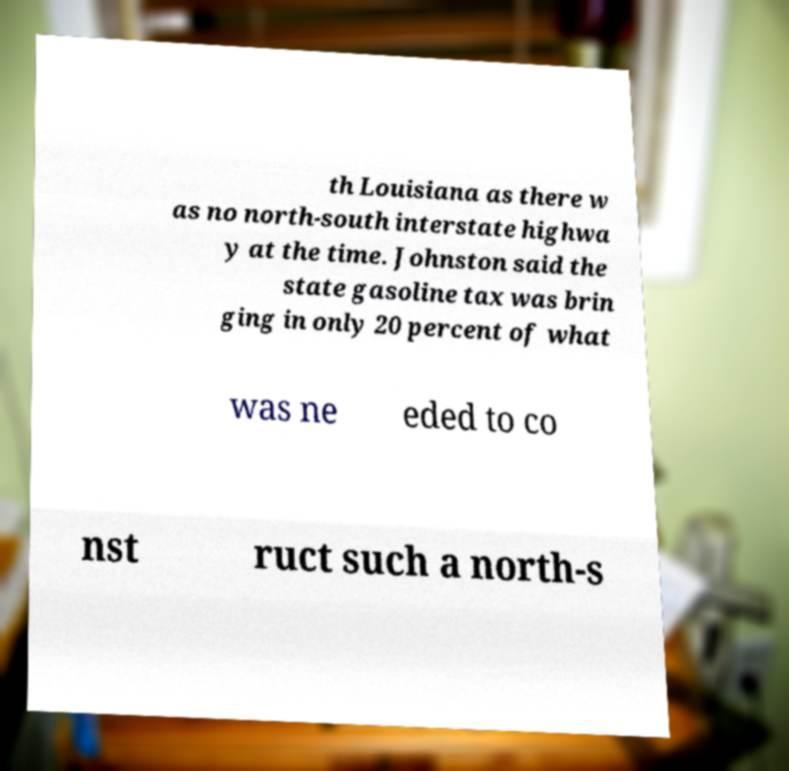Could you extract and type out the text from this image? th Louisiana as there w as no north-south interstate highwa y at the time. Johnston said the state gasoline tax was brin ging in only 20 percent of what was ne eded to co nst ruct such a north-s 